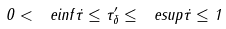Convert formula to latex. <formula><loc_0><loc_0><loc_500><loc_500>0 < \ e i n f \dot { \tau } \leq \tau _ { \delta } ^ { \prime } \leq \ e s u p \dot { \tau } \leq 1</formula> 